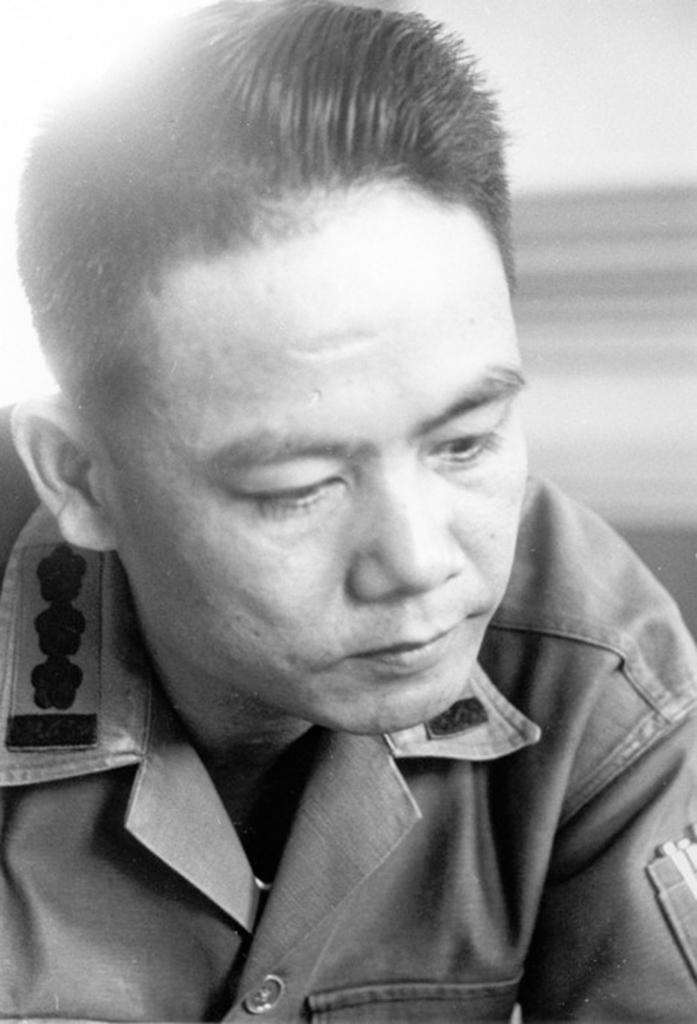What is the color scheme of the image? The image is black and white. Can you describe the main subject in the image? There is a person in the image. What is the person wearing in the image? The person is wearing a shirt. How many holes can be seen in the person's shoes in the image? There are no shoes visible in the image, and therefore no holes can be seen. 